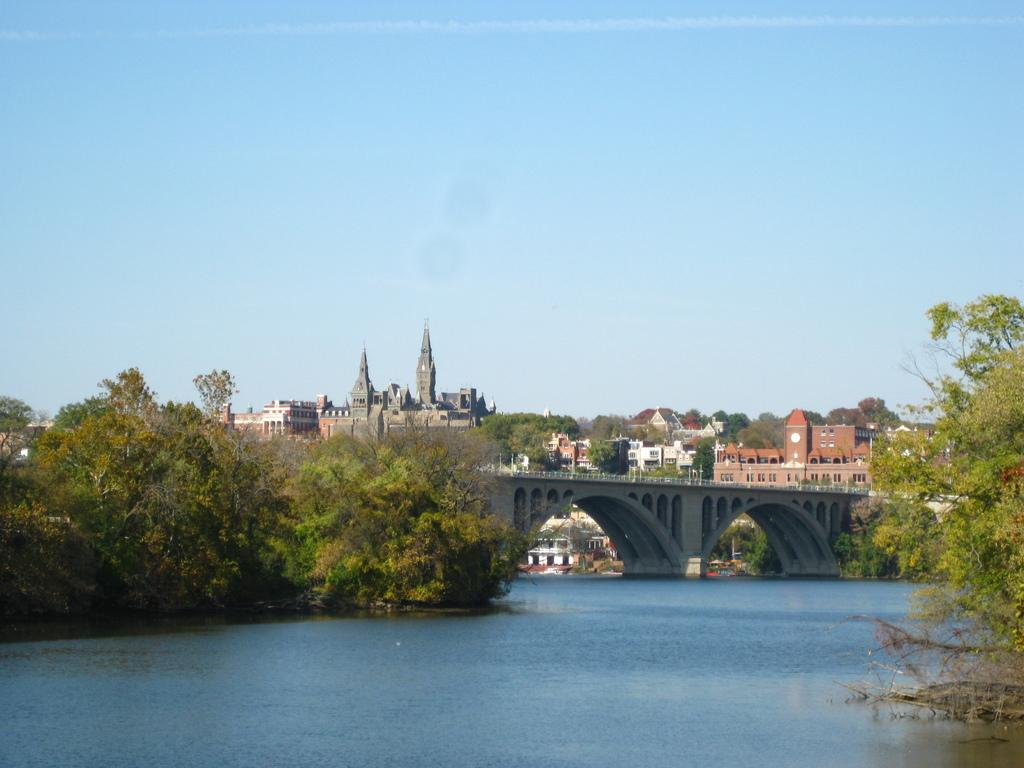What type of natural elements can be seen in the image? There are trees and water visible in the image. What man-made structure is present in the image? There is a bridge in the image. What type of human-made structures can be seen in the background? There are buildings in the image. What is visible at the top of the image? The sky is visible at the top of the image. Where is the alley located in the image? There is no alley present in the image. What type of event is taking place in the image? There is no event taking place in the image; it is a scene featuring natural and man-made elements. Can you tell me how much coal is visible in the image? There is no coal present in the image. 